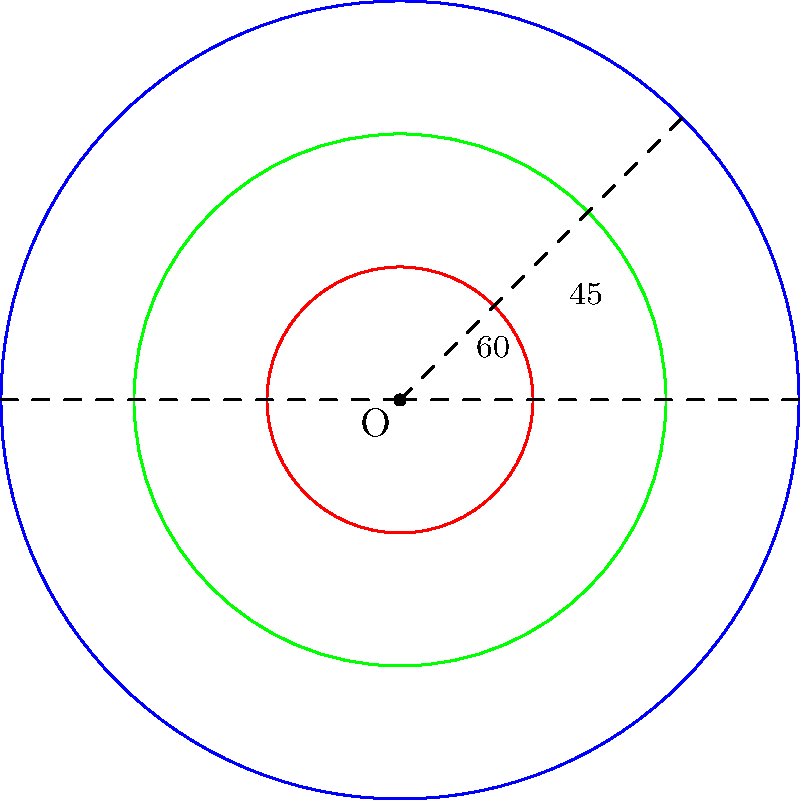In the diagram above, three aura layers are represented by concentric circles around a person's energy center O. The innermost layer (red) forms a $60°$ angle with the horizontal axis, while the middle layer (green) forms a $45°$ angle. What is the measure of the angle formed by the outermost layer (blue) with the horizontal axis? To solve this problem, we'll follow these steps:

1) First, recall that in a circle, the angle at the center is twice the angle at the circumference when both angles intercept the same arc.

2) For the innermost (red) circle:
   - The angle at the center is $60°$
   - This corresponds to a $30°$ angle at the circumference

3) For the middle (green) circle:
   - The angle at the center is $45°$
   - This corresponds to a $22.5°$ angle at the circumference

4) We can observe a pattern forming:
   - As we move outward, the angle at the circumference is halving
   - Red circle: $30°$
   - Green circle: $22.5°$ (which is $30° \times \frac{3}{4}$)

5) Following this pattern, we can predict that the angle at the circumference for the blue circle will be:
   $22.5° \times \frac{3}{4} = 16.875°$

6) To find the angle at the center for the blue circle, we double this value:
   $16.875° \times 2 = 33.75°$

Therefore, the angle formed by the outermost (blue) layer with the horizontal axis is $33.75°$.
Answer: $33.75°$ 